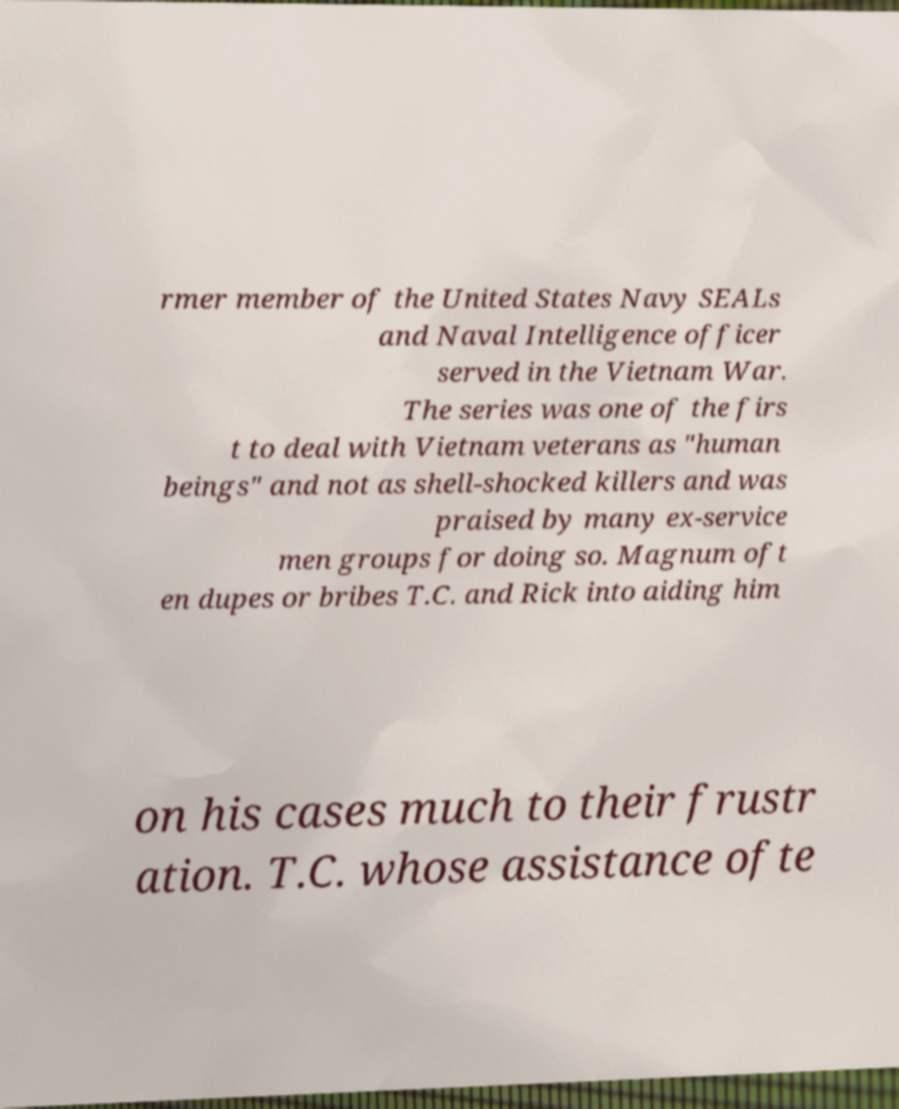For documentation purposes, I need the text within this image transcribed. Could you provide that? rmer member of the United States Navy SEALs and Naval Intelligence officer served in the Vietnam War. The series was one of the firs t to deal with Vietnam veterans as "human beings" and not as shell-shocked killers and was praised by many ex-service men groups for doing so. Magnum oft en dupes or bribes T.C. and Rick into aiding him on his cases much to their frustr ation. T.C. whose assistance ofte 